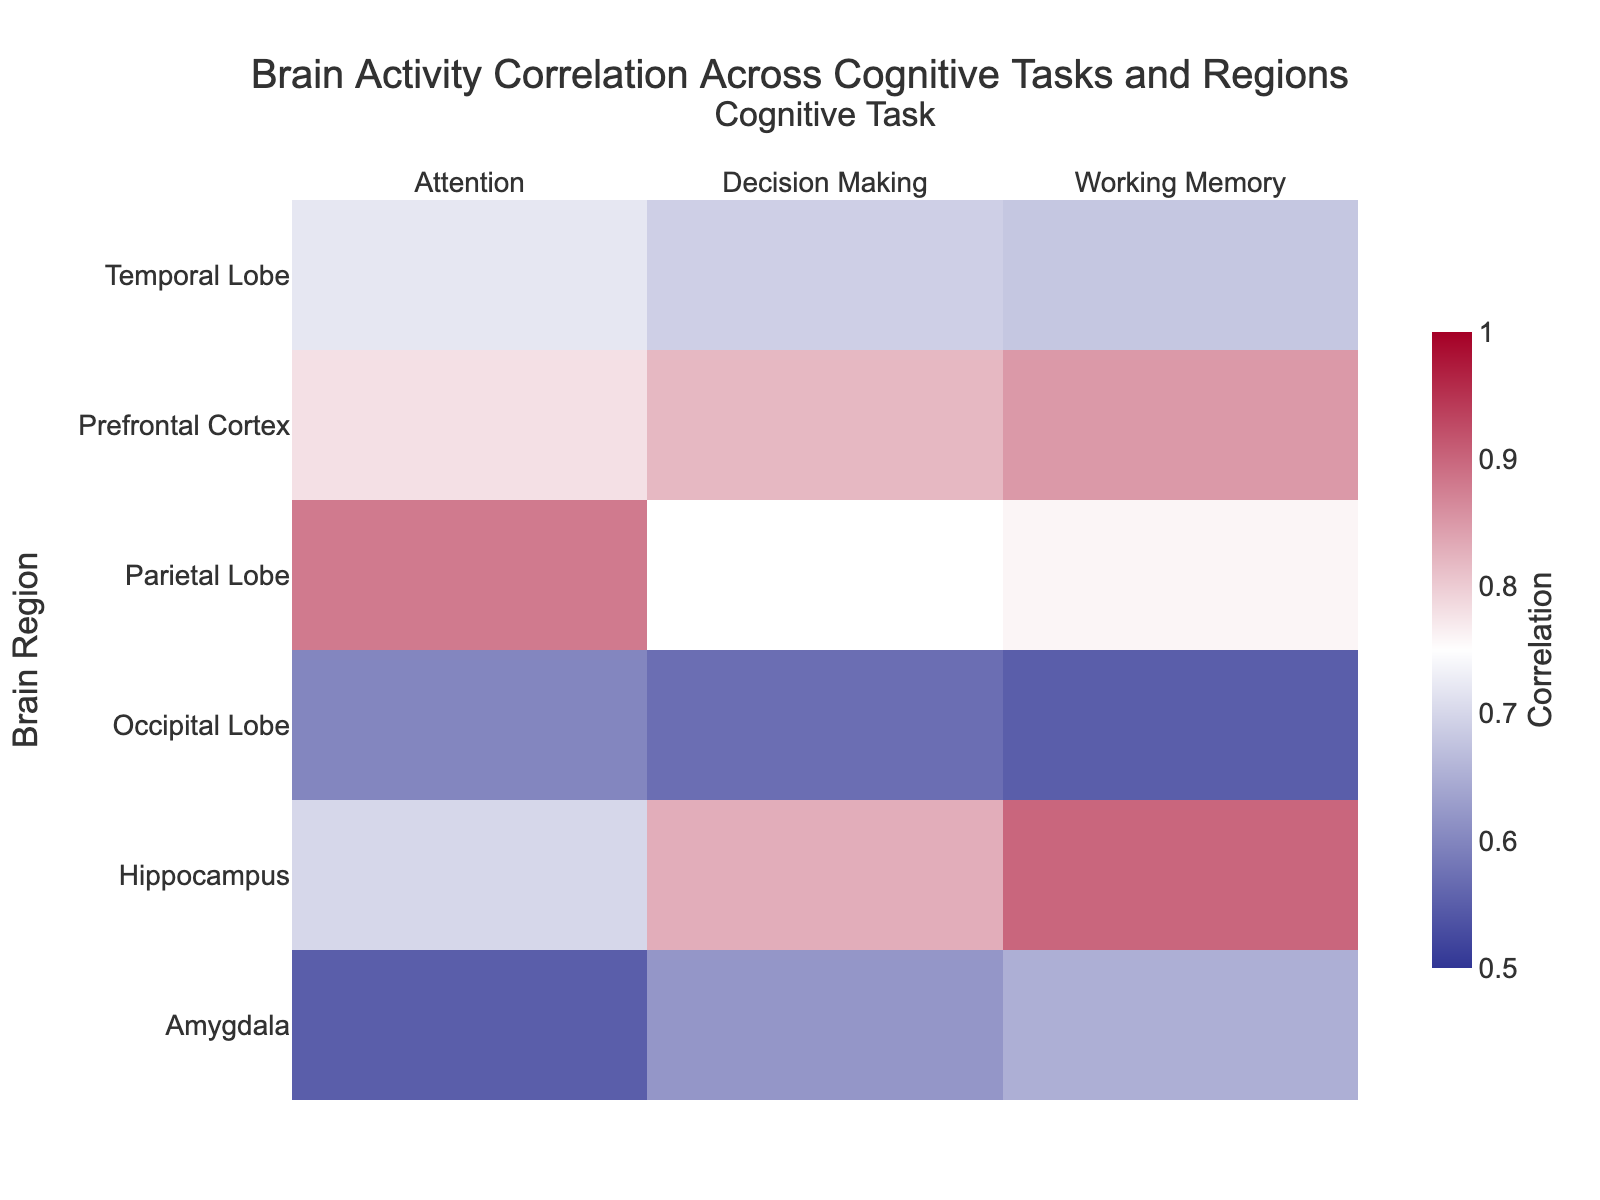What's the title of the heatmap? The title can be found at the top center of the heatmap. Reading it directly gives us the title.
Answer: Brain Activity Correlation Across Cognitive Tasks and Regions What region shows the highest correlation with Working Memory? Examine the 'Working Memory' column and find the highest value. The highest correlation for Working Memory is 0.90, which is in the Hippocampus.
Answer: Hippocampus Which cognitive task has the lowest overall correlation across all regions? Compare the correlation values for each cognitive task by examining each column. Attention has multiple low correlations, with values as low as 0.55, lower than the minimums in other tasks.
Answer: Attention Which region has the most consistent correlation across all cognitive tasks? Look for the region with the smallest range (difference between max and min) in correlation values across all tasks. The Prefrontal Cortex has correlations ranging from 0.78 to 0.85, a smaller range compared to other regions.
Answer: Prefrontal Cortex What is the average correlation of the Occipital Lobe across all cognitive tasks? Add the correlation values for the Occipital Lobe and divide by the number of tasks. (0.55 + 0.60 + 0.57) / 3 = 1.72 / 3.
Answer: 0.57 Which two regions have the highest correlation with Decision Making? Check the 'Decision Making' column for the highest values. The Prefrontal Cortex and Hippocampus both have high correlations, 0.82 and 0.83 respectively.
Answer: Prefrontal Cortex and Hippocampus What is the correlation difference between the Prefrontal Cortex and Amygdala for Working Memory? Find the correlation values for both regions for Working Memory: Prefrontal Cortex (0.85), Amygdala (0.65). Subtract the smaller from the larger value: 0.85 - 0.65 = 0.20.
Answer: 0.20 Which region has the lowest correlation with Attention? Find the minimum value in the 'Attention' column. The lowest value is 0.55 in the Amygdala.
Answer: Amygdala Compare the correlations of the Hippocampus with Working Memory and Decision Making. Are they similar? Check the 'Working Memory' (0.90) and 'Decision Making' (0.83) values for the Hippocampus. The difference is small (0.07), indicating they are relatively similar.
Answer: Yes What is the sum of the highest correlations for each cognitive task? Identify and sum the maximum correlation values for each task: Working Memory (0.90), Attention (0.88), Decision Making (0.83). 0.90 + 0.88 + 0.83 = 2.61.
Answer: 2.61 